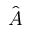<formula> <loc_0><loc_0><loc_500><loc_500>\hat { \boldsymbol A }</formula> 